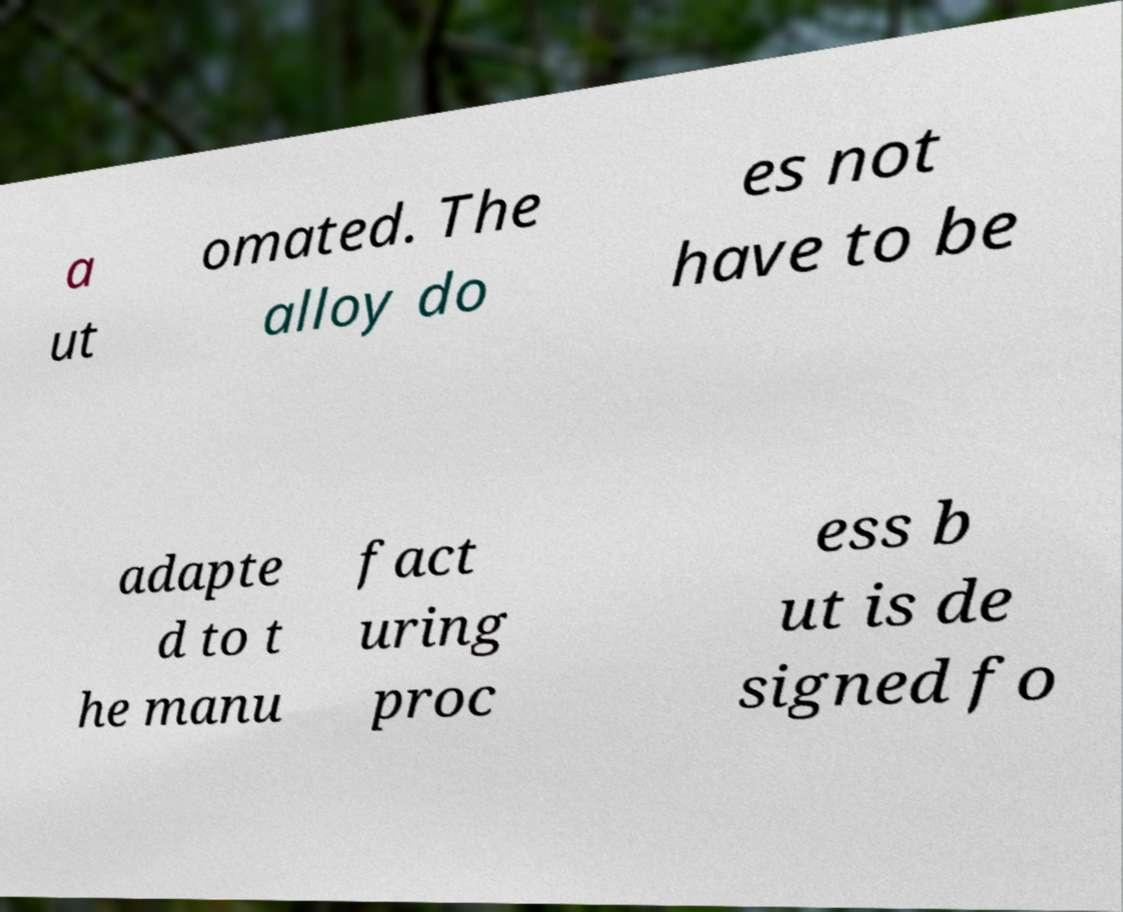What messages or text are displayed in this image? I need them in a readable, typed format. a ut omated. The alloy do es not have to be adapte d to t he manu fact uring proc ess b ut is de signed fo 